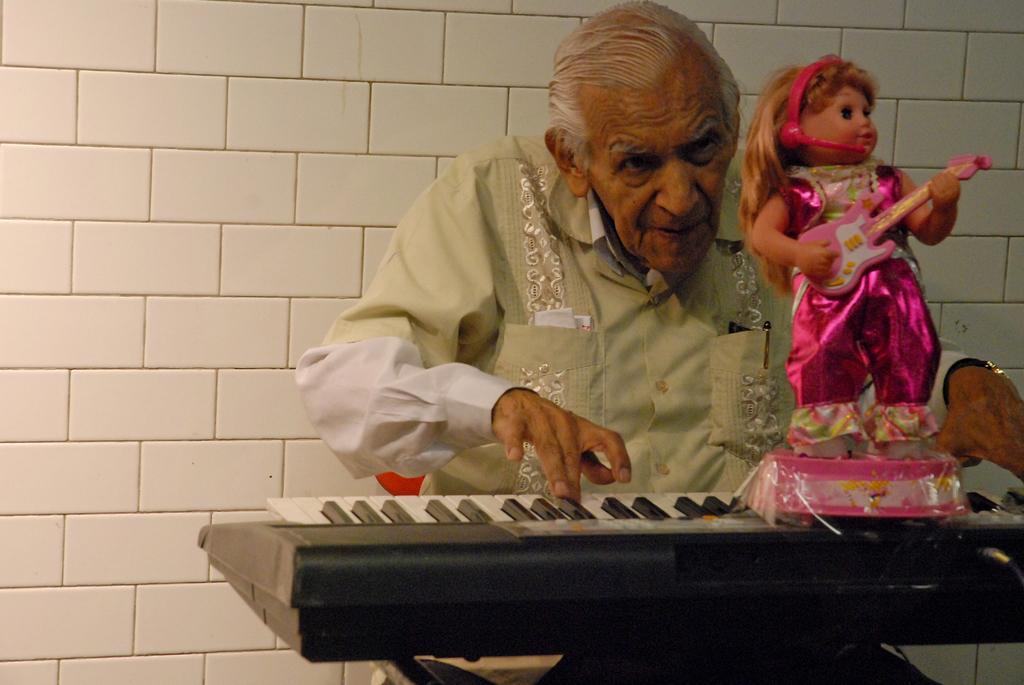Can you describe this image briefly? In this picture I can see there is a old man sitting and playing the piano and he is wearing a cream shirt and there is a pen and few papers in his pocket. There is a doll placed on the piano and it is wearing a pink dress and playing the guitar. There is a wall in the backdrop there is a wall and it is made of tiles. 